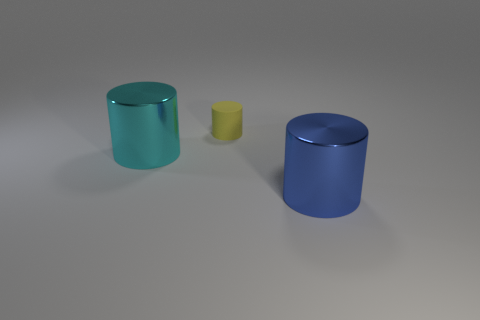There is a metallic object that is the same size as the cyan cylinder; what is its shape?
Give a very brief answer. Cylinder. What size is the blue cylinder?
Offer a very short reply. Large. What is the cylinder left of the small object that is on the right side of the shiny object that is left of the large blue metallic cylinder made of?
Make the answer very short. Metal. What is the color of the other object that is made of the same material as the blue thing?
Your answer should be very brief. Cyan. There is a object in front of the large cylinder that is behind the big blue shiny cylinder; how many blue shiny cylinders are in front of it?
Give a very brief answer. 0. Are there any other things that have the same shape as the yellow thing?
Provide a succinct answer. Yes. How many things are things on the right side of the tiny object or yellow rubber objects?
Keep it short and to the point. 2. There is a big shiny cylinder that is on the left side of the big blue shiny cylinder; does it have the same color as the small object?
Your answer should be compact. No. There is a thing that is behind the big thing that is to the left of the big blue metal object; what shape is it?
Provide a succinct answer. Cylinder. Are there fewer shiny cylinders behind the tiny yellow matte object than yellow cylinders that are behind the blue cylinder?
Provide a short and direct response. Yes. 